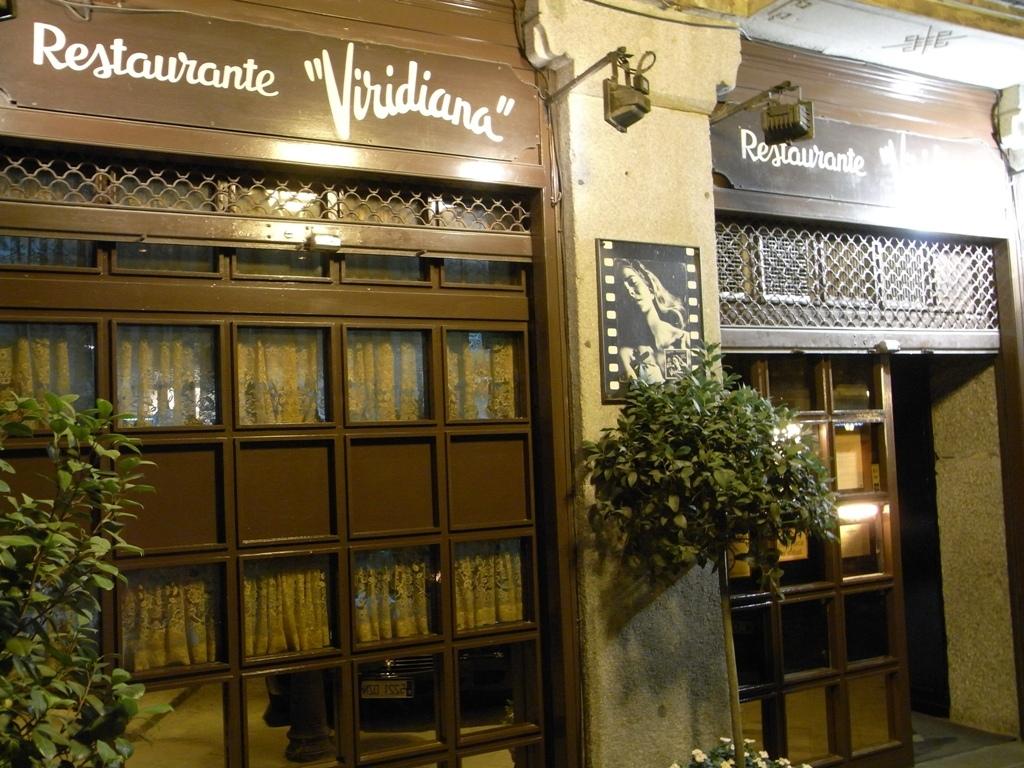What is the name of the restaurant?
Offer a very short reply. Viridiana. 